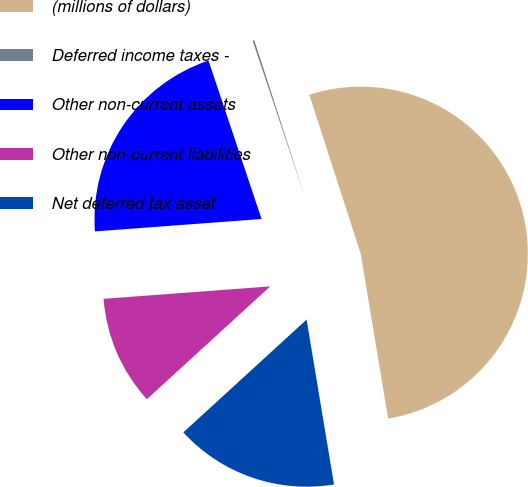Convert chart. <chart><loc_0><loc_0><loc_500><loc_500><pie_chart><fcel>(millions of dollars)<fcel>Deferred income taxes -<fcel>Other non-current assets<fcel>Other non-current liabilities<fcel>Net deferred tax asset<nl><fcel>52.36%<fcel>0.17%<fcel>21.04%<fcel>10.61%<fcel>15.83%<nl></chart> 